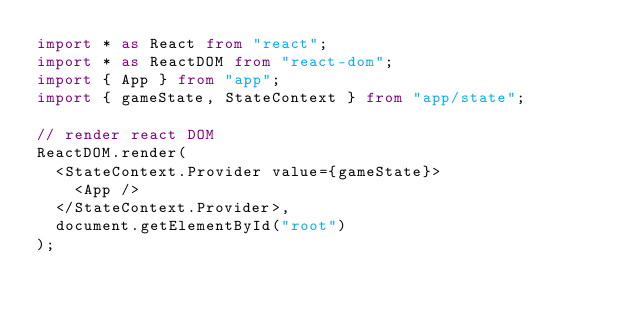Convert code to text. <code><loc_0><loc_0><loc_500><loc_500><_TypeScript_>import * as React from "react";
import * as ReactDOM from "react-dom";
import { App } from "app";
import { gameState, StateContext } from "app/state";

// render react DOM
ReactDOM.render(
  <StateContext.Provider value={gameState}>
    <App />
  </StateContext.Provider>,
  document.getElementById("root")
);
</code> 